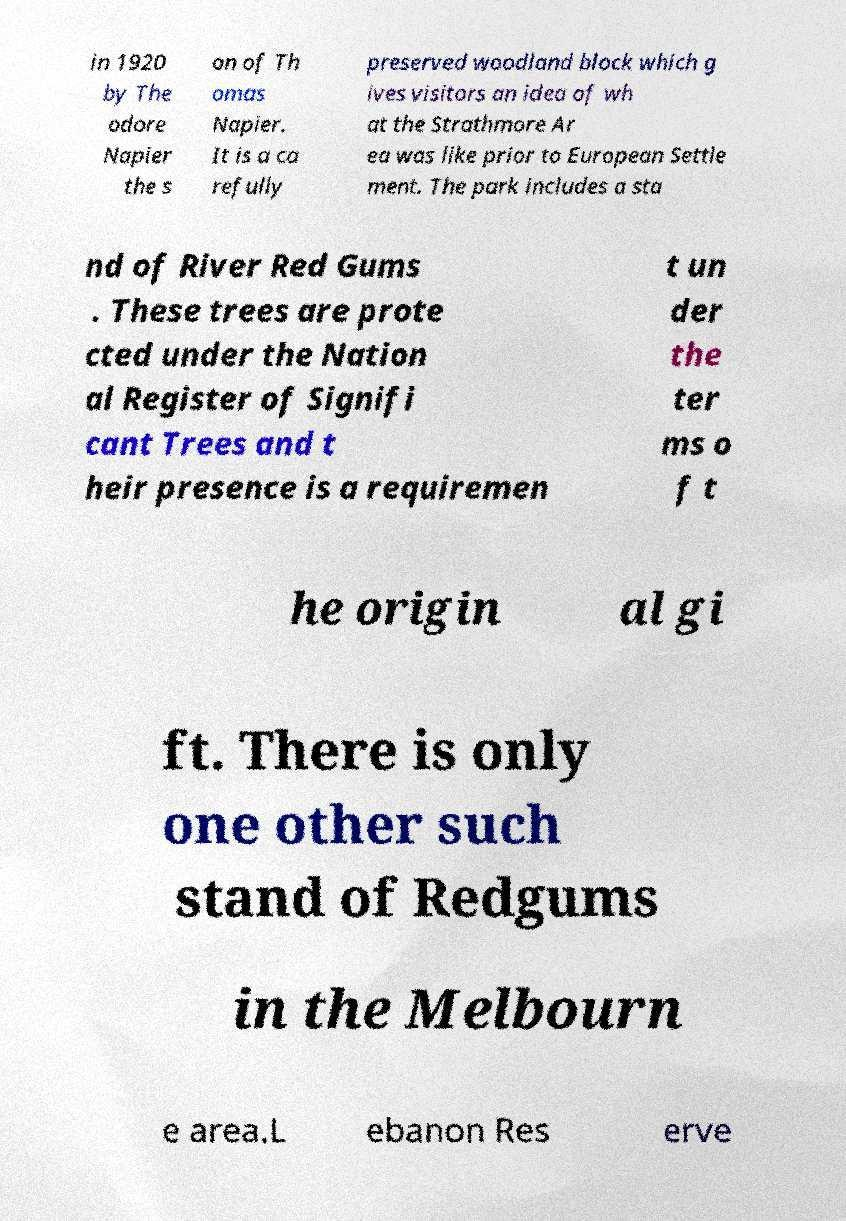Please identify and transcribe the text found in this image. in 1920 by The odore Napier the s on of Th omas Napier. It is a ca refully preserved woodland block which g ives visitors an idea of wh at the Strathmore Ar ea was like prior to European Settle ment. The park includes a sta nd of River Red Gums . These trees are prote cted under the Nation al Register of Signifi cant Trees and t heir presence is a requiremen t un der the ter ms o f t he origin al gi ft. There is only one other such stand of Redgums in the Melbourn e area.L ebanon Res erve 